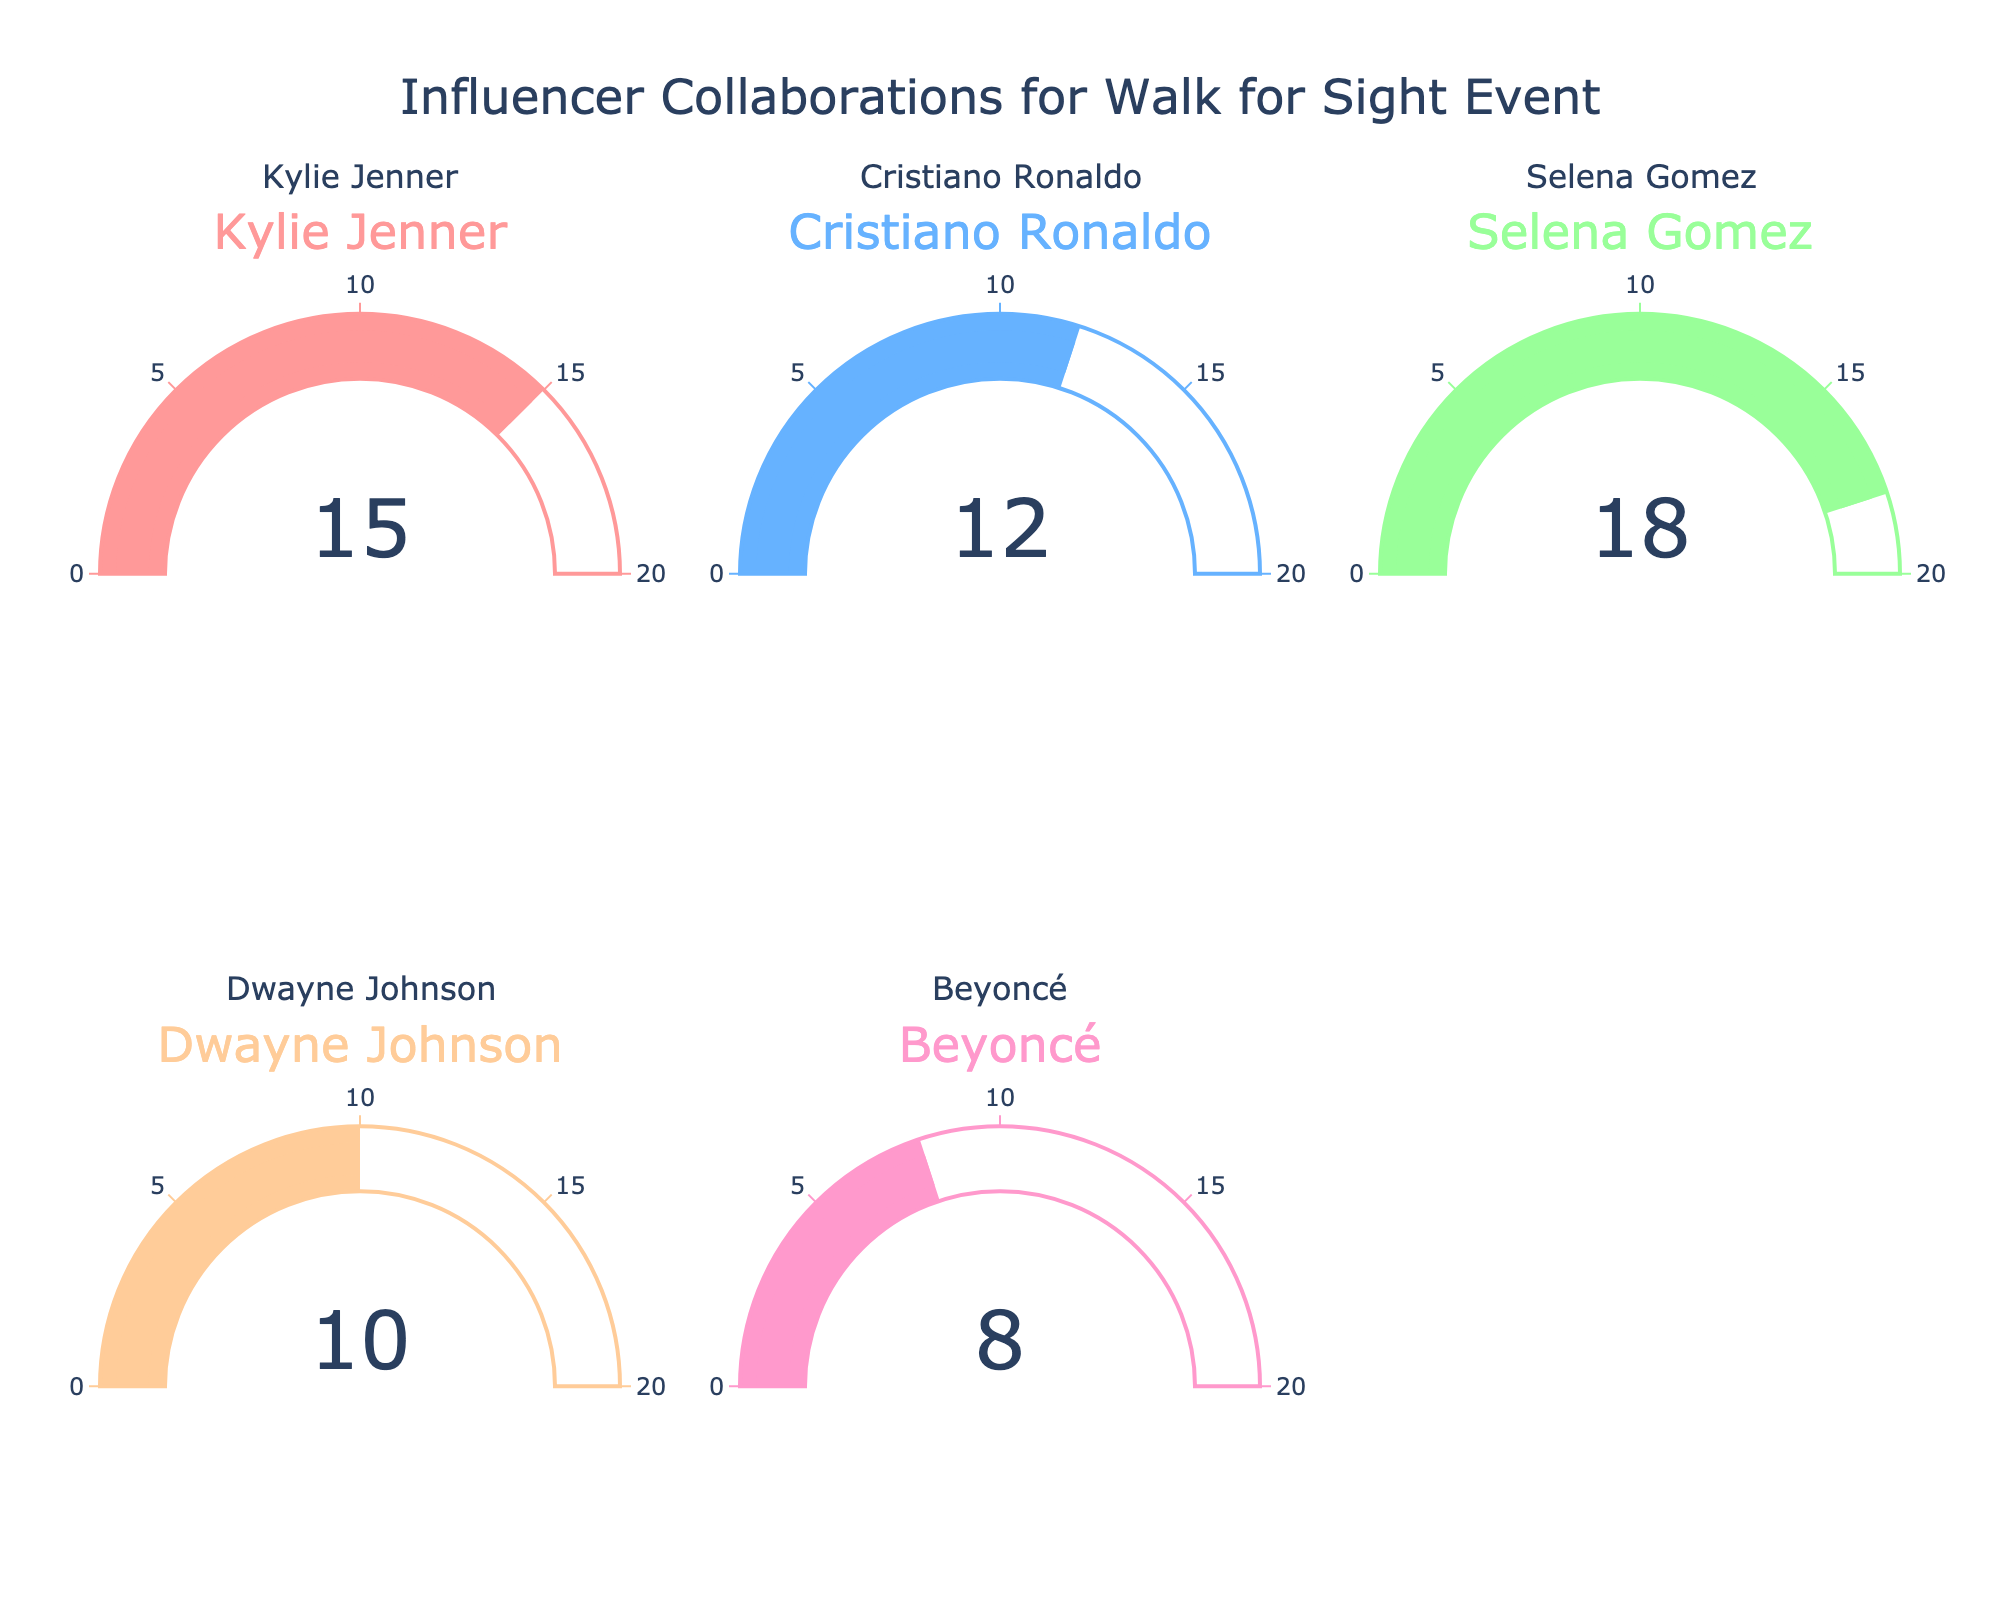what is the number of collaborations secured with Kylie Jenner? The gauge chart for Kylie Jenner shows a value representing the number of collaborations. By looking at that specific gauge, we see that it reads 15.
Answer: 15 Which influencer has secured the most collaborations? To identify the influencer with the most collaborations, compare the values in the gauge charts for each influencer. From the figure, Selena Gomez has the highest value of 18 collaborations.
Answer: Selena Gomez What is the total number of collaborations by all influencers? Sum the values shown in the gauge charts for all influencers. The values are: 15 (Kylie Jenner) + 12 (Cristiano Ronaldo) + 18 (Selena Gomez) + 10 (Dwayne Johnson) + 8 (Beyoncé). The total is 63.
Answer: 63 Are there any influencers with fewer than 10 collaborations? From the gauge charts, we can see that Dwayne Johnson has 10 collaborations, and Beyoncé has 8 collaborations. Thus, only Beyoncé has fewer than 10 collaborations.
Answer: Beyoncé How many more collaborations does Selena Gomez have compared to Cristiano Ronaldo? Identify the values from the gauge charts: Selena Gomez has 18 collaborations, and Cristiano Ronaldo has 12. Subtract the value for Cristiano from Selena's value: 18 - 12 = 6.
Answer: 6 Which influencers have secured at least 10 collaborations? From the gauge charts, identify the influencers with values of 10 or more. Kylie Jenner (15), Cristiano Ronaldo (12), Selena Gomez (18), and Dwayne Johnson (10) have secured at least 10 collaborations.
Answer: Kylie Jenner, Cristiano Ronaldo, Selena Gomez, Dwayne Johnson What is the average number of collaborations per influencer? Sum the number of collaborations (15 + 12 + 18 + 10 + 8 = 63) and divide by the number of influencers (5). The average is 63 / 5 = 12.6.
Answer: 12.6 How does the number of collaborations secured by Kylie Jenner compare to Dwayne Johnson? From the gauge charts, Kylie Jenner has 15 collaborations and Dwayne Johnson has 10. Kylie Jenner has more collaborations compared to Dwayne Johnson.
Answer: Kylie Jenner What is the median number of collaborations among the influencers? First, arrange the numbers of collaborations in ascending order: 8, 10, 12, 15, 18. The median is the middle value, which is 12.
Answer: 12 